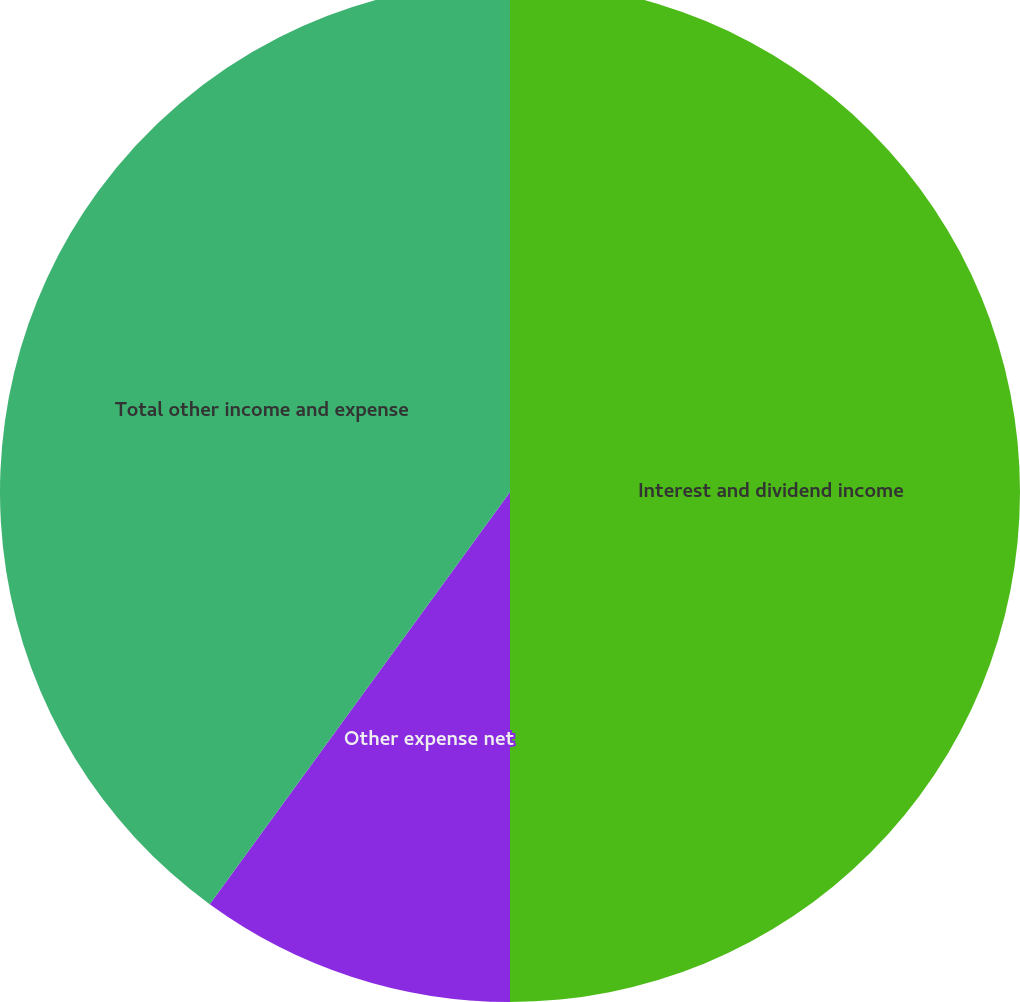Convert chart to OTSL. <chart><loc_0><loc_0><loc_500><loc_500><pie_chart><fcel>Interest and dividend income<fcel>Other expense net<fcel>Total other income and expense<nl><fcel>50.0%<fcel>10.02%<fcel>39.98%<nl></chart> 